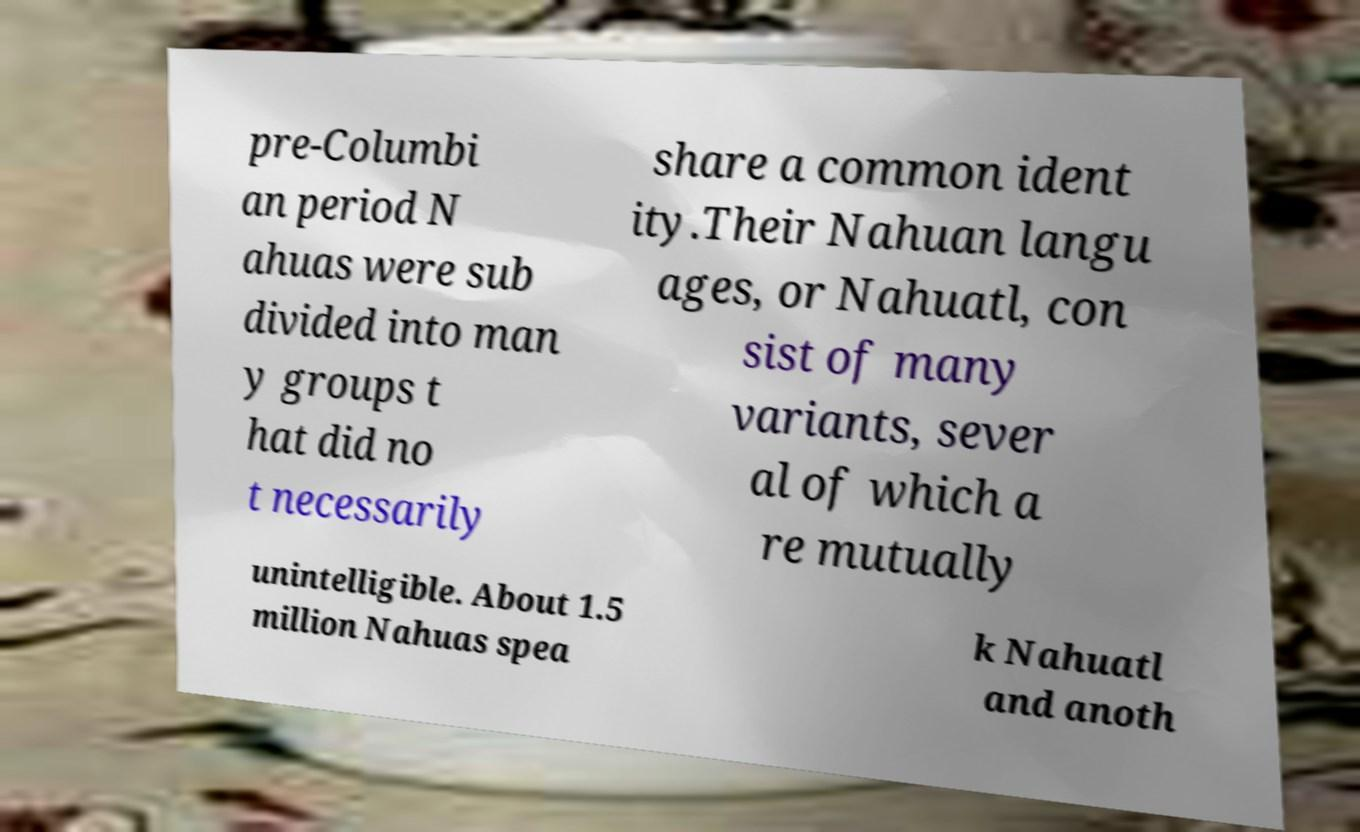Please read and relay the text visible in this image. What does it say? pre-Columbi an period N ahuas were sub divided into man y groups t hat did no t necessarily share a common ident ity.Their Nahuan langu ages, or Nahuatl, con sist of many variants, sever al of which a re mutually unintelligible. About 1.5 million Nahuas spea k Nahuatl and anoth 